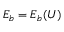<formula> <loc_0><loc_0><loc_500><loc_500>E _ { b } = E _ { b } ( U )</formula> 